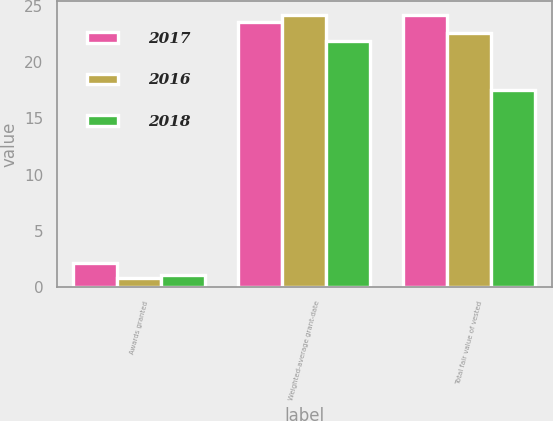Convert chart. <chart><loc_0><loc_0><loc_500><loc_500><stacked_bar_chart><ecel><fcel>Awards granted<fcel>Weighted-average grant-date<fcel>Total fair value of vested<nl><fcel>2017<fcel>2.1<fcel>23.6<fcel>24.2<nl><fcel>2016<fcel>0.8<fcel>24.18<fcel>22.6<nl><fcel>2018<fcel>1.1<fcel>21.87<fcel>17.5<nl></chart> 